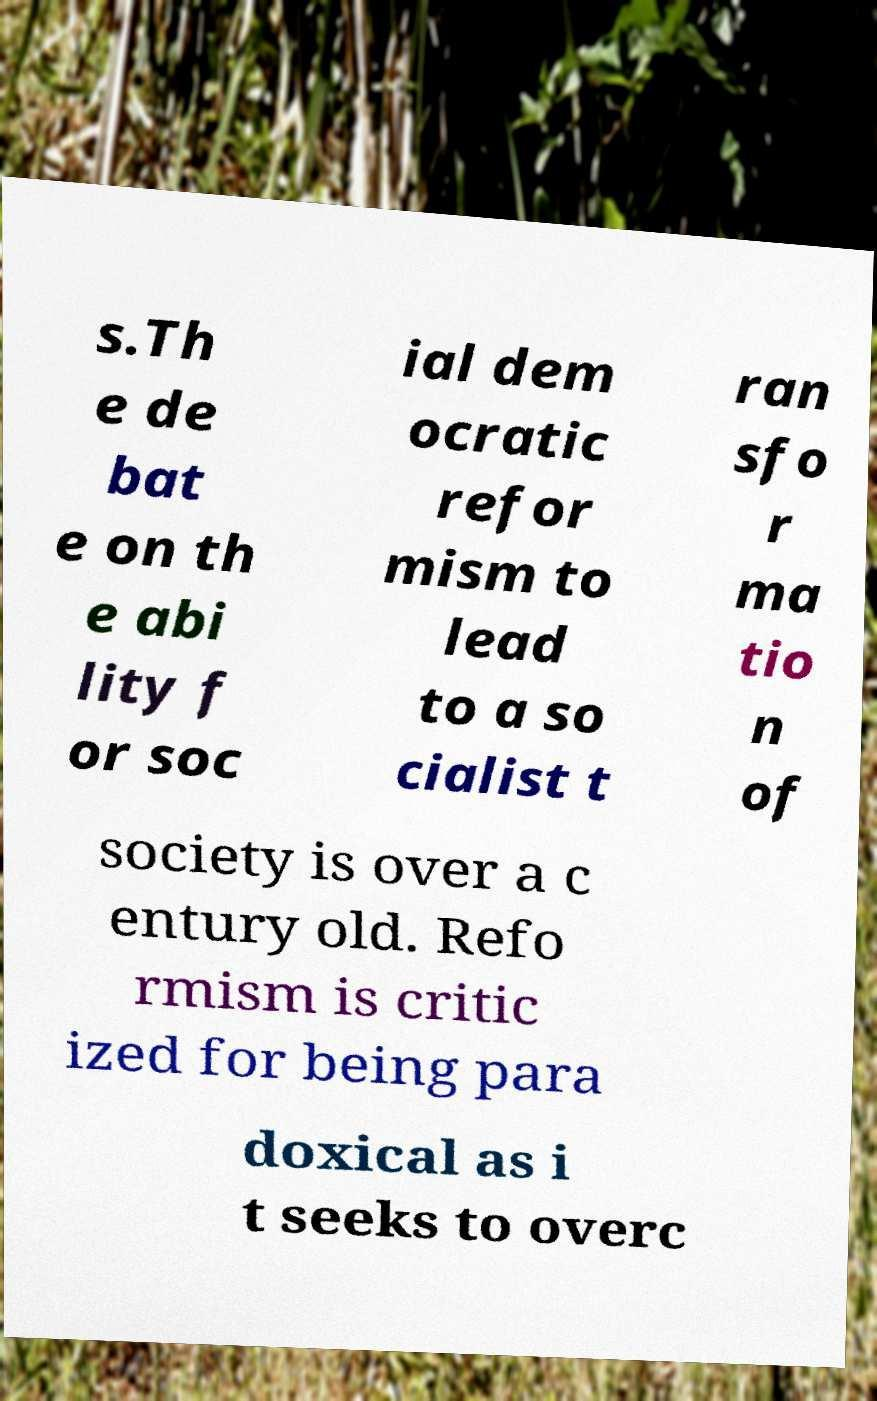Can you accurately transcribe the text from the provided image for me? s.Th e de bat e on th e abi lity f or soc ial dem ocratic refor mism to lead to a so cialist t ran sfo r ma tio n of society is over a c entury old. Refo rmism is critic ized for being para doxical as i t seeks to overc 